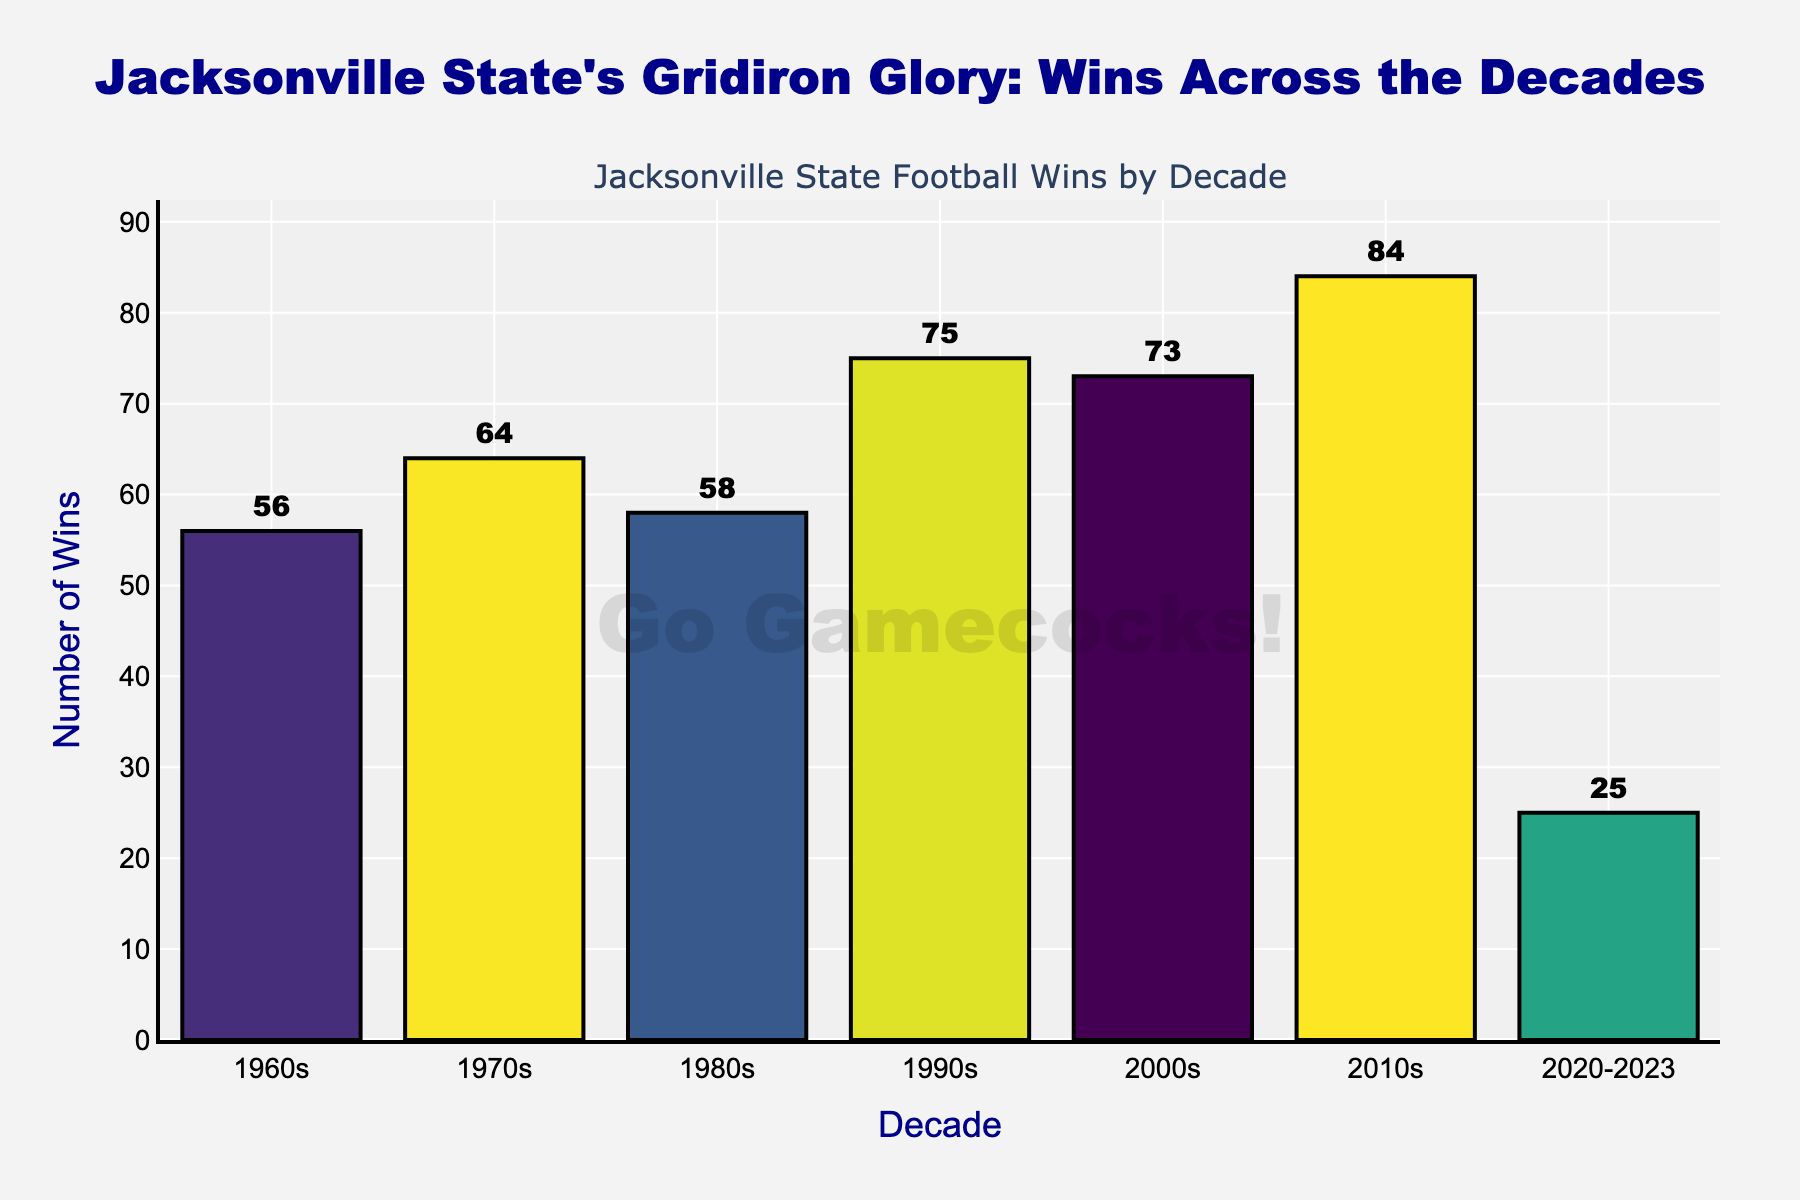What's the total number of wins in the 1990s and 2000s? Add the wins from the 1990s (75) and the 2000s (73) together: 75 + 73.
Answer: 148 Which decade had the highest number of wins? Compare the wins in each decade. The 2010s had 84 wins, which is the highest.
Answer: 2010s Which decade had more wins: the 1980s or the 2020-2023 period? Compare the wins from the 1980s (58) and the 2020-2023 period (25). 58 is greater than 25.
Answer: 1980s By how much did the number of wins increase from the 1960s to the 2010s? Subtract the wins in the 1960s (56) from the wins in the 2010s (84): 84 - 56.
Answer: 28 What’s the average number of wins per year during the 2020-2023 period? The period 2020-2023 covers 4 years, and there were 25 wins in this period. Divide the number of wins by the number of years: 25 / 4.
Answer: 6.25 Which decade saw a bigger increase in wins compared to the previous one: the 1980s or the 2010s? Calculate the difference for both: 1970s-1960s (64 - 56 = 8), 1990s-1980s (75 - 58 = 17). The increase from the 1980s to the 1990s is bigger (17).
Answer: 1990s (from the 1980s) What is the difference between the highest and lowest number of wins across the decades? Identify the highest (84 in the 2010s) and lowest (25 in the 2020-2023), then subtract: 84 - 25.
Answer: 59 What visual attribute indicates the number of wins in each decade? The height of the bars represents the number of wins. Taller bars indicate more wins.
Answer: Height of bars How many more wins were there in the 1990s compared to the 1960s? Subtract the wins in the 1960s (56) from the wins in the 1990s (75): 75 - 56.
Answer: 19 Which decade had fewer wins, the 2000s or the 2020-2023 period? Compare the wins from the 2000s (73) and the 2020-2023 period (25). 25 is fewer than 73.
Answer: 2020-2023 